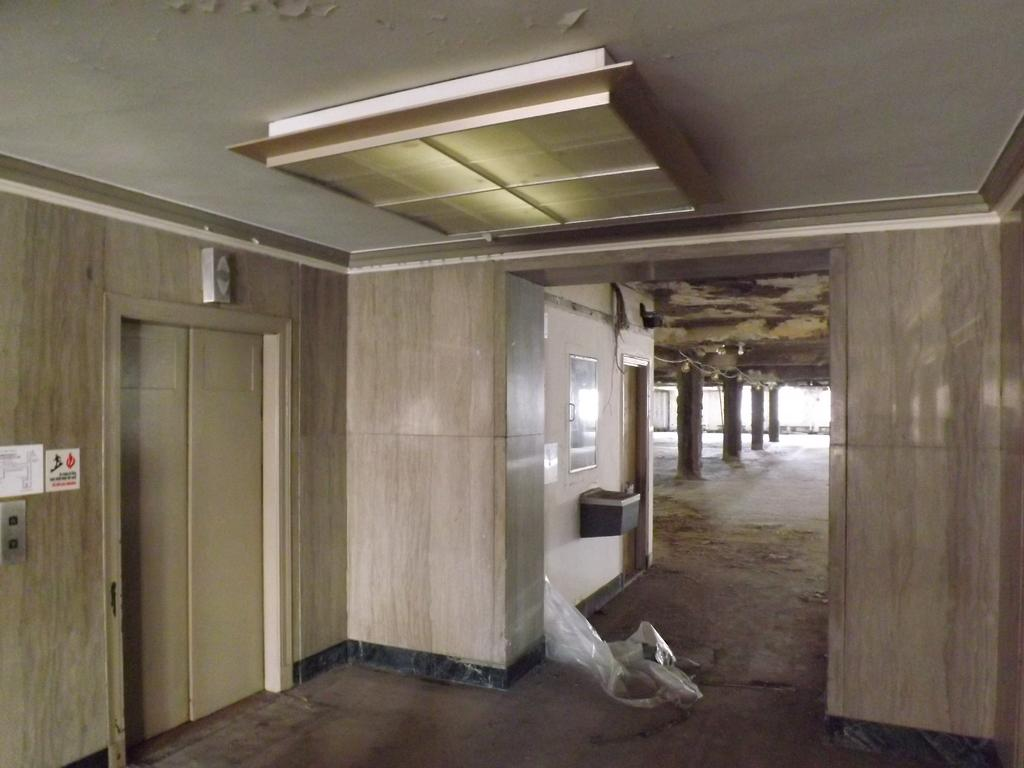What type of location is depicted in the image? The image shows an inside view of a building. What can be seen in the middle of the image? There is a plastic cover in the middle of the image. What is on the wall on the left side of the image? There are posters on the wall on the left side of the image. What direction is the watch pointing to in the image? There is no watch present in the image. How many chairs are visible in the image? There are no chairs visible in the image. 